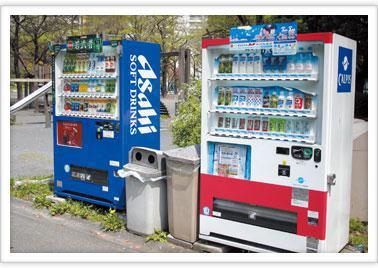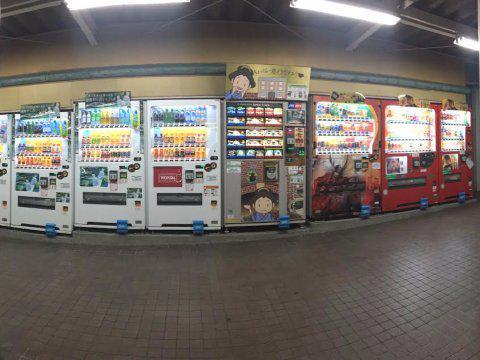The first image is the image on the left, the second image is the image on the right. Examine the images to the left and right. Is the description "In a row of at least five vending machines, one machine is gray." accurate? Answer yes or no. Yes. The first image is the image on the left, the second image is the image on the right. Analyze the images presented: Is the assertion "One of the images shows a white vending machine that offers plates of food instead of beverages." valid? Answer yes or no. No. 